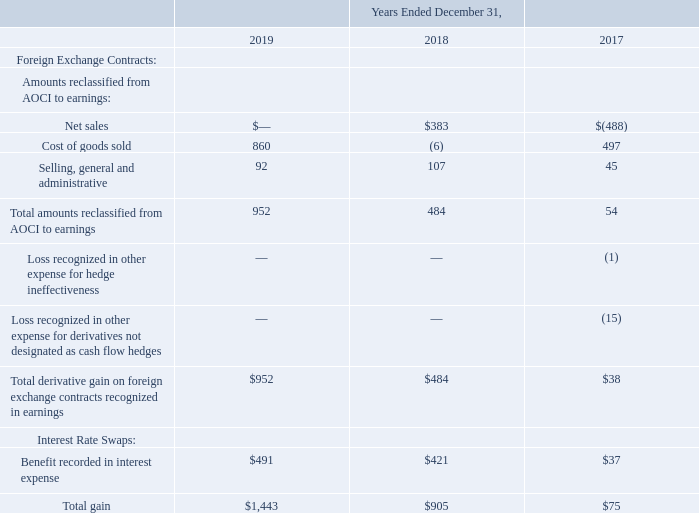NOTES TO CONSOLIDATED FINANCIAL STATEMENTS (in thousands, except for share and per share data)
NOTE 13 — Derivatives
The effect of derivative instruments on the Consolidated Statements of Earnings is as follows:
Which years does the table provide information for the  effect of derivative instruments on the Consolidated Statements of Earnings? 2019, 2018, 2017. What were the net sales in 2018?
Answer scale should be: thousand. 383. What was the Cost of goods sold in 2017?
Answer scale should be: thousand. 497. What was the change in the Net sales between 2017 and 2018?
Answer scale should be: thousand. 383-(-488)
Answer: 871. What was the change in the Selling, general and administrative between 2018 and 2019?
Answer scale should be: thousand. 92-107
Answer: -15. What was percentage change in the total gain between 2018 and 2019?
Answer scale should be: percent. (1,443-905)/905
Answer: 59.45. 